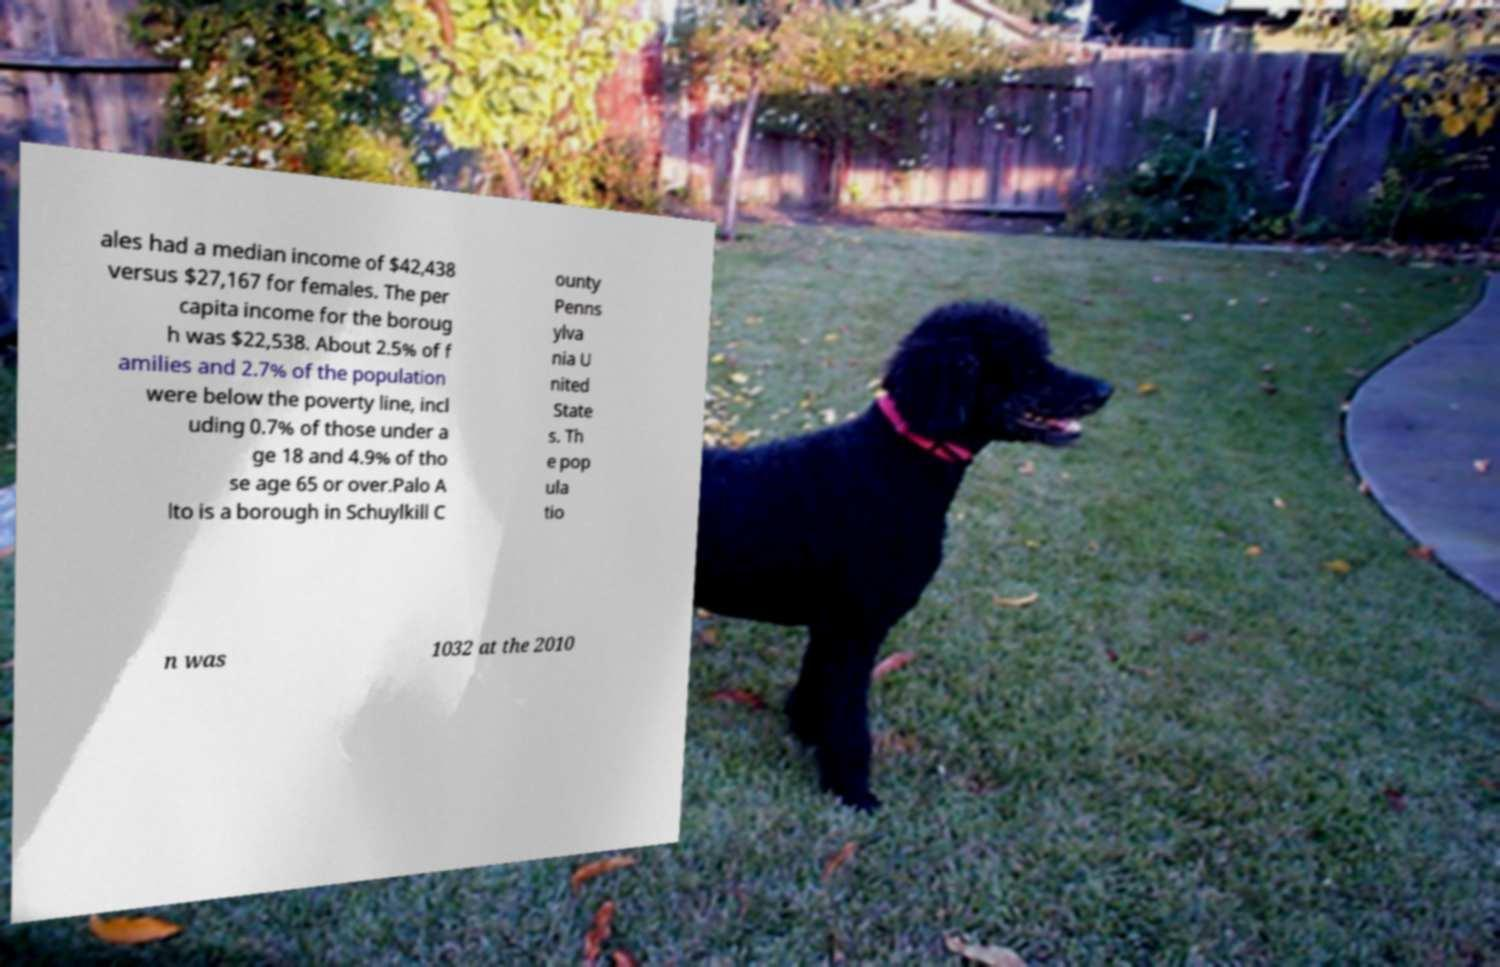Please read and relay the text visible in this image. What does it say? ales had a median income of $42,438 versus $27,167 for females. The per capita income for the boroug h was $22,538. About 2.5% of f amilies and 2.7% of the population were below the poverty line, incl uding 0.7% of those under a ge 18 and 4.9% of tho se age 65 or over.Palo A lto is a borough in Schuylkill C ounty Penns ylva nia U nited State s. Th e pop ula tio n was 1032 at the 2010 